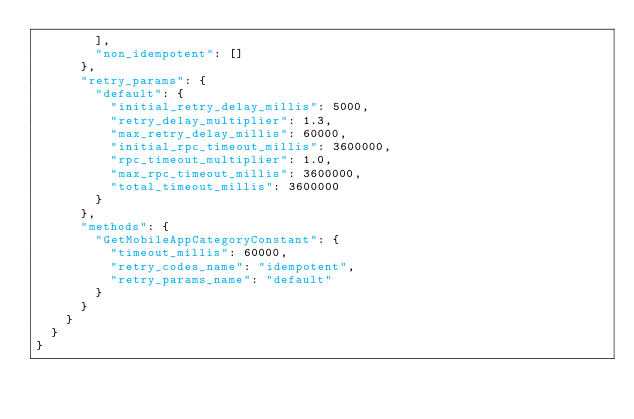<code> <loc_0><loc_0><loc_500><loc_500><_Python_>        ],
        "non_idempotent": []
      },
      "retry_params": {
        "default": {
          "initial_retry_delay_millis": 5000,
          "retry_delay_multiplier": 1.3,
          "max_retry_delay_millis": 60000,
          "initial_rpc_timeout_millis": 3600000,
          "rpc_timeout_multiplier": 1.0,
          "max_rpc_timeout_millis": 3600000,
          "total_timeout_millis": 3600000
        }
      },
      "methods": {
        "GetMobileAppCategoryConstant": {
          "timeout_millis": 60000,
          "retry_codes_name": "idempotent",
          "retry_params_name": "default"
        }
      }
    }
  }
}
</code> 